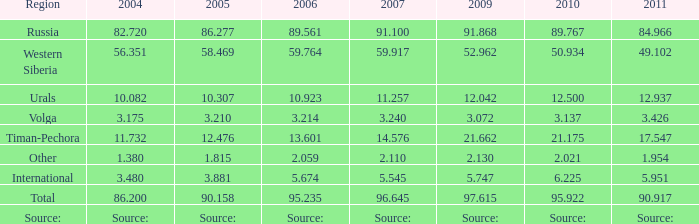662 million tonnes? 21.175. 